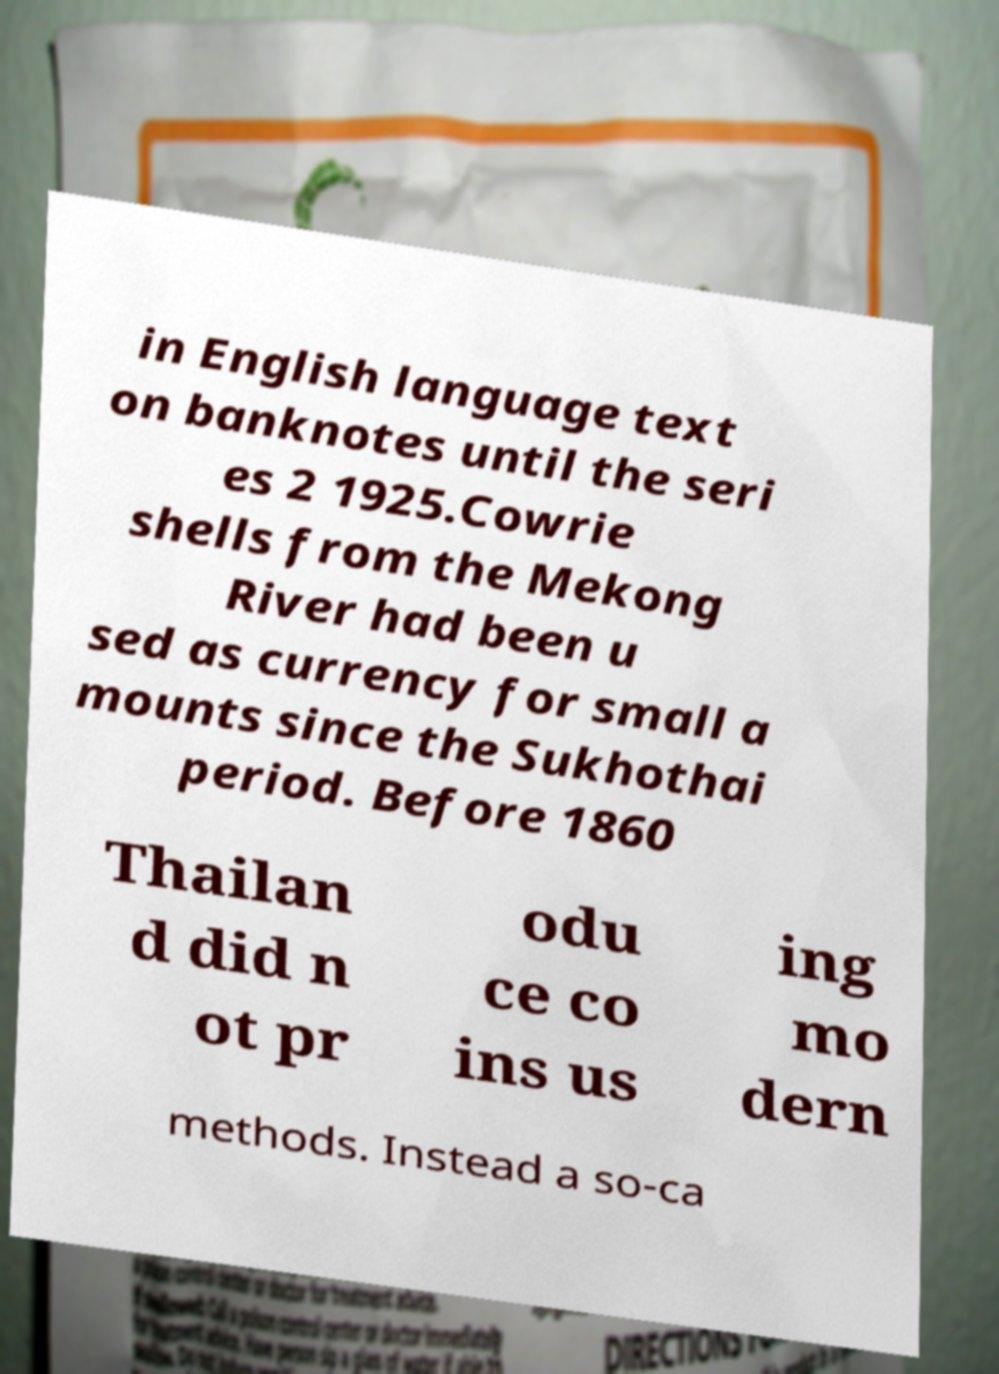Can you read and provide the text displayed in the image?This photo seems to have some interesting text. Can you extract and type it out for me? in English language text on banknotes until the seri es 2 1925.Cowrie shells from the Mekong River had been u sed as currency for small a mounts since the Sukhothai period. Before 1860 Thailan d did n ot pr odu ce co ins us ing mo dern methods. Instead a so-ca 